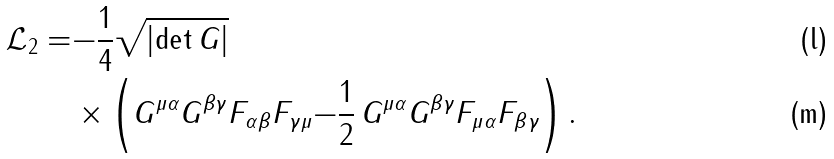<formula> <loc_0><loc_0><loc_500><loc_500>\mathcal { L } _ { 2 } = & { - \frac { 1 } { 4 } } \sqrt { \left | \det G \right | } \, \\ & \times \left ( G ^ { \mu \alpha } G ^ { \beta \gamma } F _ { \alpha \beta } F _ { \gamma \mu } { - \frac { 1 } { 2 } \, G ^ { \mu \alpha } G ^ { \beta \gamma } F _ { \mu \alpha } F _ { \beta \gamma } } \right ) .</formula> 